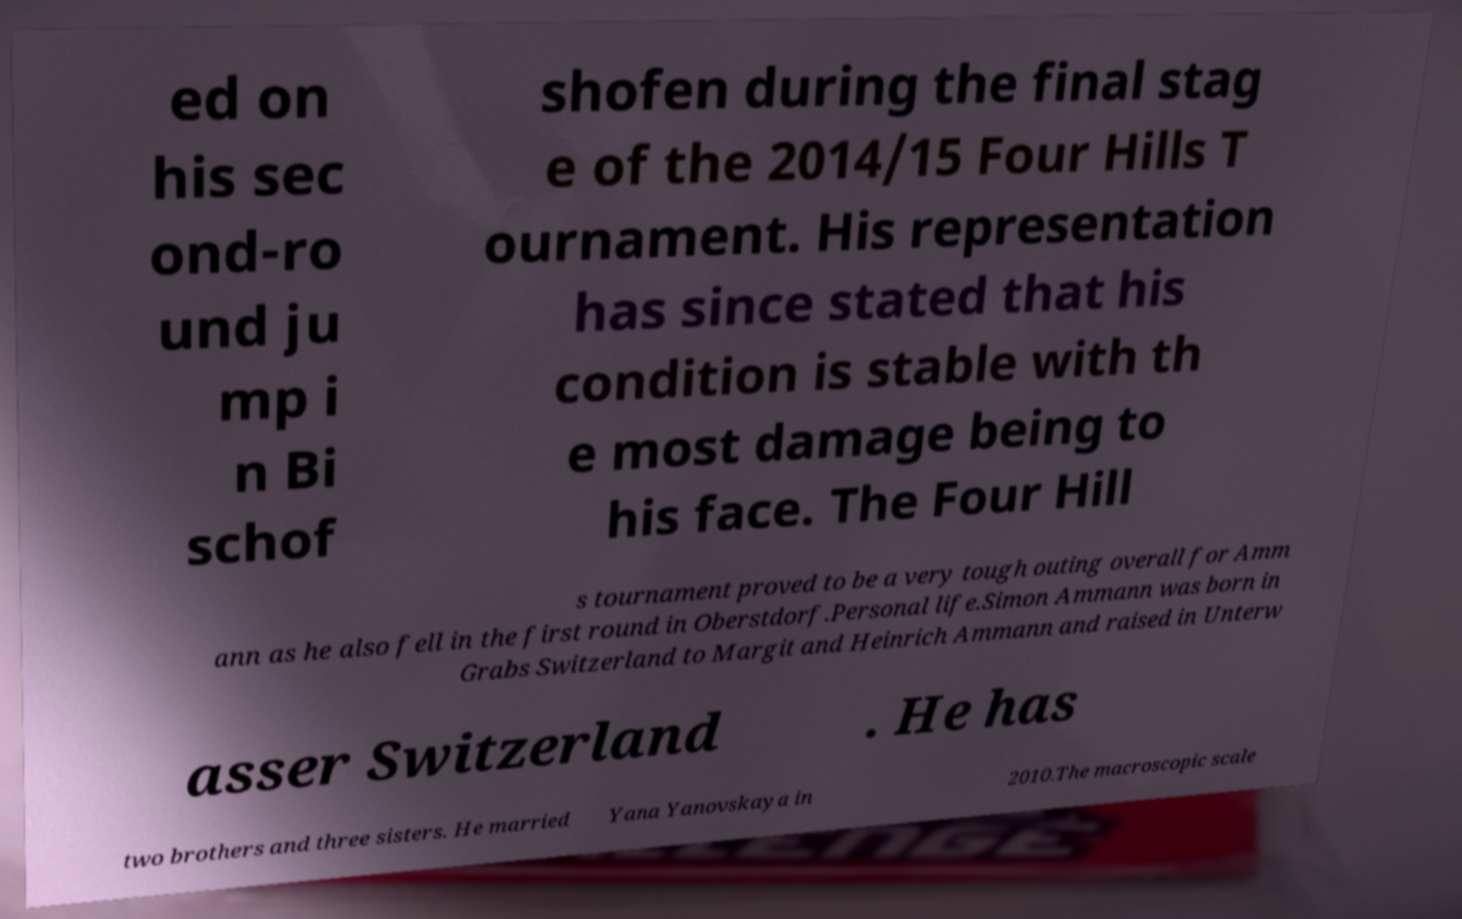Please identify and transcribe the text found in this image. ed on his sec ond-ro und ju mp i n Bi schof shofen during the final stag e of the 2014/15 Four Hills T ournament. His representation has since stated that his condition is stable with th e most damage being to his face. The Four Hill s tournament proved to be a very tough outing overall for Amm ann as he also fell in the first round in Oberstdorf.Personal life.Simon Ammann was born in Grabs Switzerland to Margit and Heinrich Ammann and raised in Unterw asser Switzerland . He has two brothers and three sisters. He married Yana Yanovskaya in 2010.The macroscopic scale 